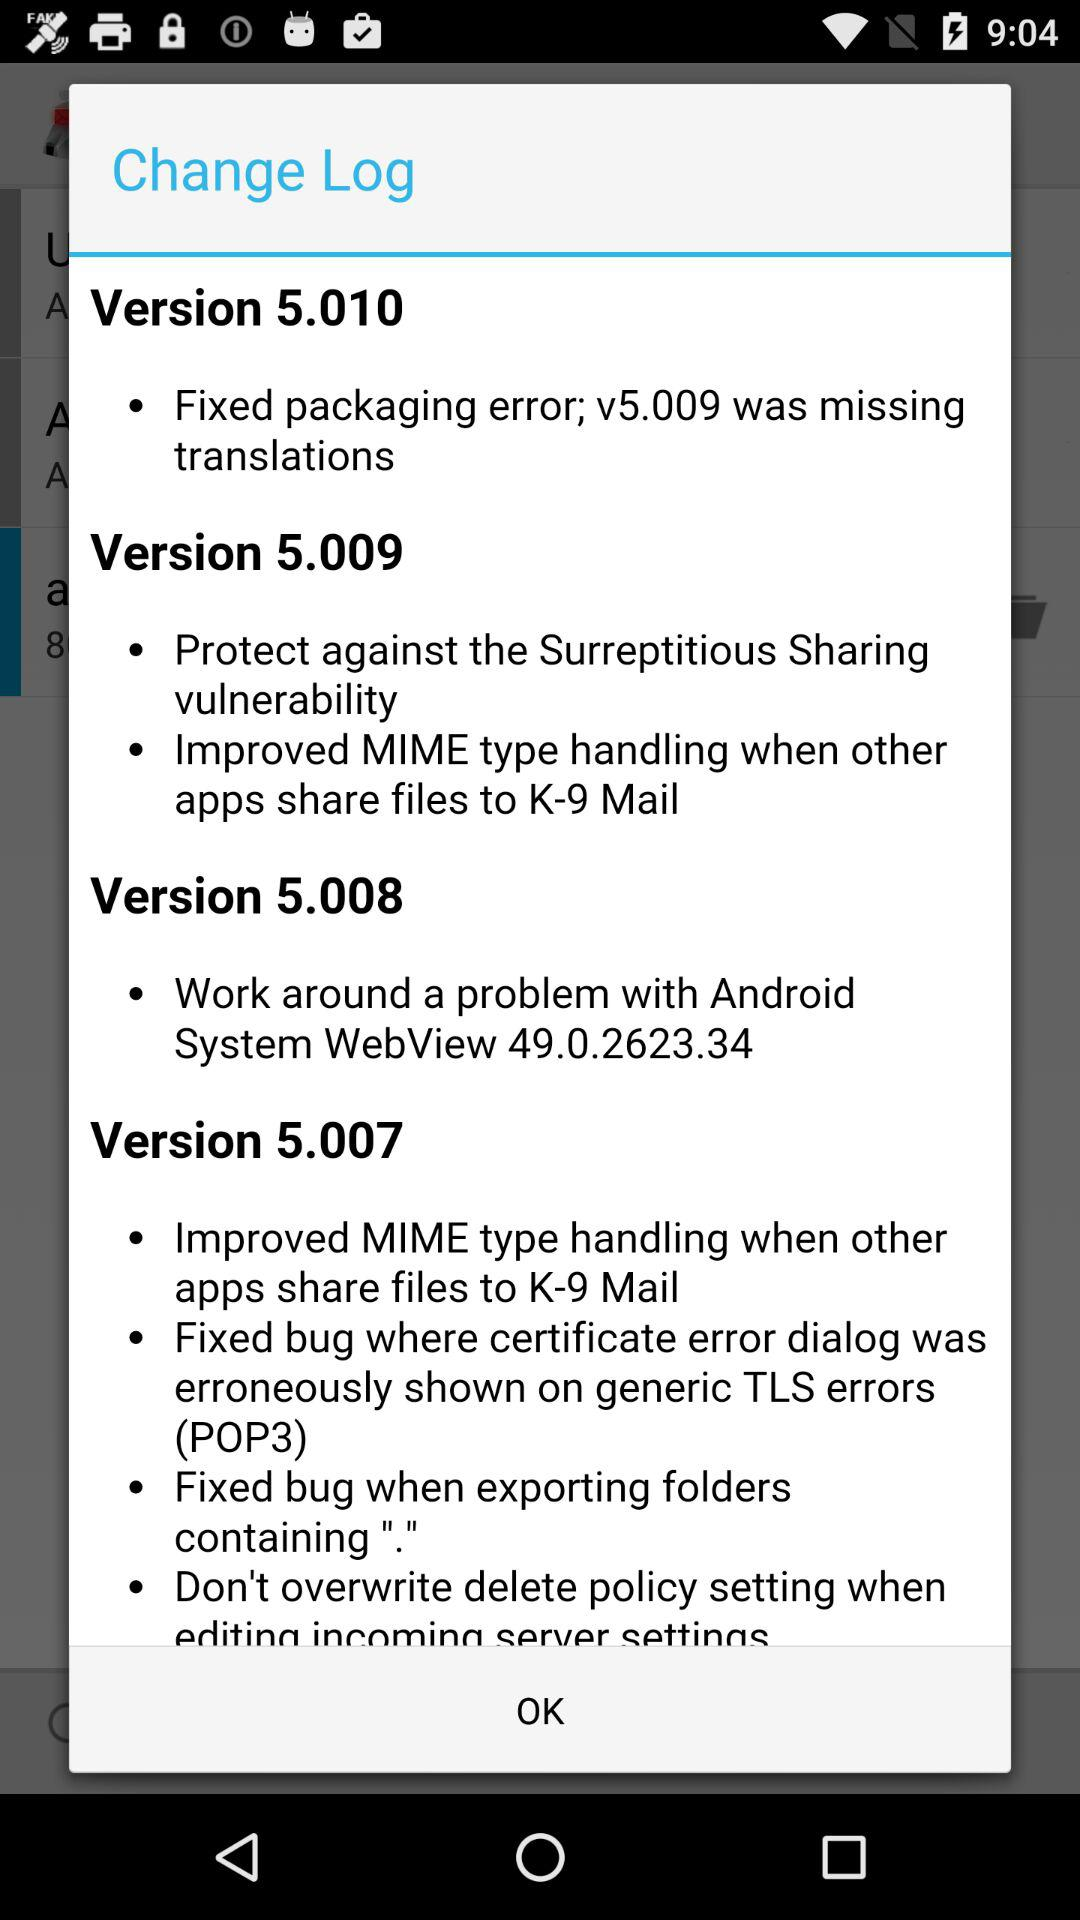How many bugs were fixed in version 5.009?
Answer the question using a single word or phrase. 2 